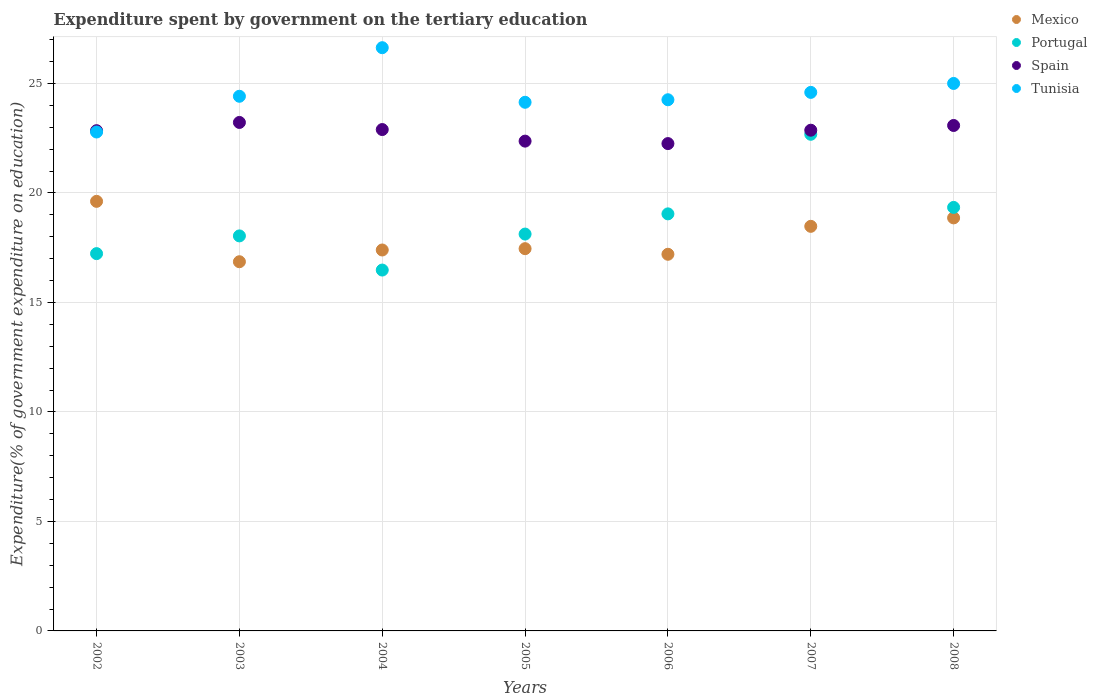Is the number of dotlines equal to the number of legend labels?
Provide a short and direct response. Yes. What is the expenditure spent by government on the tertiary education in Portugal in 2005?
Ensure brevity in your answer.  18.12. Across all years, what is the maximum expenditure spent by government on the tertiary education in Spain?
Make the answer very short. 23.22. Across all years, what is the minimum expenditure spent by government on the tertiary education in Spain?
Offer a terse response. 22.25. In which year was the expenditure spent by government on the tertiary education in Mexico maximum?
Make the answer very short. 2002. In which year was the expenditure spent by government on the tertiary education in Portugal minimum?
Make the answer very short. 2004. What is the total expenditure spent by government on the tertiary education in Tunisia in the graph?
Ensure brevity in your answer.  171.81. What is the difference between the expenditure spent by government on the tertiary education in Mexico in 2005 and that in 2006?
Give a very brief answer. 0.26. What is the difference between the expenditure spent by government on the tertiary education in Spain in 2008 and the expenditure spent by government on the tertiary education in Tunisia in 2007?
Make the answer very short. -1.51. What is the average expenditure spent by government on the tertiary education in Portugal per year?
Your answer should be very brief. 18.7. In the year 2007, what is the difference between the expenditure spent by government on the tertiary education in Tunisia and expenditure spent by government on the tertiary education in Portugal?
Your answer should be very brief. 1.91. In how many years, is the expenditure spent by government on the tertiary education in Tunisia greater than 2 %?
Provide a short and direct response. 7. What is the ratio of the expenditure spent by government on the tertiary education in Spain in 2002 to that in 2004?
Make the answer very short. 1. Is the expenditure spent by government on the tertiary education in Spain in 2006 less than that in 2008?
Ensure brevity in your answer.  Yes. What is the difference between the highest and the second highest expenditure spent by government on the tertiary education in Portugal?
Give a very brief answer. 3.34. What is the difference between the highest and the lowest expenditure spent by government on the tertiary education in Mexico?
Give a very brief answer. 2.76. Is the sum of the expenditure spent by government on the tertiary education in Mexico in 2003 and 2008 greater than the maximum expenditure spent by government on the tertiary education in Spain across all years?
Offer a terse response. Yes. Is it the case that in every year, the sum of the expenditure spent by government on the tertiary education in Mexico and expenditure spent by government on the tertiary education in Spain  is greater than the expenditure spent by government on the tertiary education in Portugal?
Keep it short and to the point. Yes. Does the expenditure spent by government on the tertiary education in Spain monotonically increase over the years?
Provide a short and direct response. No. Is the expenditure spent by government on the tertiary education in Spain strictly greater than the expenditure spent by government on the tertiary education in Mexico over the years?
Your response must be concise. Yes. Does the graph contain any zero values?
Provide a short and direct response. No. How are the legend labels stacked?
Offer a terse response. Vertical. What is the title of the graph?
Provide a succinct answer. Expenditure spent by government on the tertiary education. What is the label or title of the X-axis?
Give a very brief answer. Years. What is the label or title of the Y-axis?
Your answer should be compact. Expenditure(% of government expenditure on education). What is the Expenditure(% of government expenditure on education) in Mexico in 2002?
Your answer should be compact. 19.62. What is the Expenditure(% of government expenditure on education) in Portugal in 2002?
Your response must be concise. 17.23. What is the Expenditure(% of government expenditure on education) of Spain in 2002?
Make the answer very short. 22.84. What is the Expenditure(% of government expenditure on education) in Tunisia in 2002?
Your answer should be very brief. 22.78. What is the Expenditure(% of government expenditure on education) in Mexico in 2003?
Your answer should be compact. 16.86. What is the Expenditure(% of government expenditure on education) in Portugal in 2003?
Your answer should be very brief. 18.04. What is the Expenditure(% of government expenditure on education) of Spain in 2003?
Provide a short and direct response. 23.22. What is the Expenditure(% of government expenditure on education) of Tunisia in 2003?
Offer a very short reply. 24.41. What is the Expenditure(% of government expenditure on education) of Mexico in 2004?
Your answer should be very brief. 17.39. What is the Expenditure(% of government expenditure on education) in Portugal in 2004?
Keep it short and to the point. 16.48. What is the Expenditure(% of government expenditure on education) in Spain in 2004?
Your response must be concise. 22.89. What is the Expenditure(% of government expenditure on education) in Tunisia in 2004?
Your answer should be very brief. 26.63. What is the Expenditure(% of government expenditure on education) in Mexico in 2005?
Make the answer very short. 17.45. What is the Expenditure(% of government expenditure on education) in Portugal in 2005?
Your response must be concise. 18.12. What is the Expenditure(% of government expenditure on education) of Spain in 2005?
Your answer should be compact. 22.37. What is the Expenditure(% of government expenditure on education) of Tunisia in 2005?
Give a very brief answer. 24.14. What is the Expenditure(% of government expenditure on education) in Mexico in 2006?
Your response must be concise. 17.2. What is the Expenditure(% of government expenditure on education) of Portugal in 2006?
Offer a terse response. 19.04. What is the Expenditure(% of government expenditure on education) of Spain in 2006?
Provide a succinct answer. 22.25. What is the Expenditure(% of government expenditure on education) of Tunisia in 2006?
Offer a terse response. 24.25. What is the Expenditure(% of government expenditure on education) of Mexico in 2007?
Provide a succinct answer. 18.47. What is the Expenditure(% of government expenditure on education) of Portugal in 2007?
Offer a terse response. 22.68. What is the Expenditure(% of government expenditure on education) of Spain in 2007?
Your answer should be very brief. 22.86. What is the Expenditure(% of government expenditure on education) in Tunisia in 2007?
Keep it short and to the point. 24.59. What is the Expenditure(% of government expenditure on education) in Mexico in 2008?
Offer a very short reply. 18.86. What is the Expenditure(% of government expenditure on education) of Portugal in 2008?
Give a very brief answer. 19.34. What is the Expenditure(% of government expenditure on education) in Spain in 2008?
Your response must be concise. 23.08. What is the Expenditure(% of government expenditure on education) in Tunisia in 2008?
Your answer should be compact. 25. Across all years, what is the maximum Expenditure(% of government expenditure on education) in Mexico?
Make the answer very short. 19.62. Across all years, what is the maximum Expenditure(% of government expenditure on education) of Portugal?
Give a very brief answer. 22.68. Across all years, what is the maximum Expenditure(% of government expenditure on education) of Spain?
Offer a very short reply. 23.22. Across all years, what is the maximum Expenditure(% of government expenditure on education) in Tunisia?
Offer a terse response. 26.63. Across all years, what is the minimum Expenditure(% of government expenditure on education) in Mexico?
Offer a very short reply. 16.86. Across all years, what is the minimum Expenditure(% of government expenditure on education) in Portugal?
Offer a terse response. 16.48. Across all years, what is the minimum Expenditure(% of government expenditure on education) of Spain?
Make the answer very short. 22.25. Across all years, what is the minimum Expenditure(% of government expenditure on education) in Tunisia?
Your answer should be very brief. 22.78. What is the total Expenditure(% of government expenditure on education) in Mexico in the graph?
Provide a short and direct response. 125.86. What is the total Expenditure(% of government expenditure on education) of Portugal in the graph?
Make the answer very short. 130.93. What is the total Expenditure(% of government expenditure on education) in Spain in the graph?
Your answer should be very brief. 159.52. What is the total Expenditure(% of government expenditure on education) in Tunisia in the graph?
Your answer should be compact. 171.81. What is the difference between the Expenditure(% of government expenditure on education) of Mexico in 2002 and that in 2003?
Provide a short and direct response. 2.76. What is the difference between the Expenditure(% of government expenditure on education) in Portugal in 2002 and that in 2003?
Your response must be concise. -0.81. What is the difference between the Expenditure(% of government expenditure on education) of Spain in 2002 and that in 2003?
Your answer should be very brief. -0.38. What is the difference between the Expenditure(% of government expenditure on education) of Tunisia in 2002 and that in 2003?
Provide a succinct answer. -1.63. What is the difference between the Expenditure(% of government expenditure on education) of Mexico in 2002 and that in 2004?
Your answer should be compact. 2.22. What is the difference between the Expenditure(% of government expenditure on education) of Portugal in 2002 and that in 2004?
Your response must be concise. 0.75. What is the difference between the Expenditure(% of government expenditure on education) in Spain in 2002 and that in 2004?
Keep it short and to the point. -0.05. What is the difference between the Expenditure(% of government expenditure on education) in Tunisia in 2002 and that in 2004?
Your answer should be compact. -3.85. What is the difference between the Expenditure(% of government expenditure on education) in Mexico in 2002 and that in 2005?
Your answer should be compact. 2.16. What is the difference between the Expenditure(% of government expenditure on education) of Portugal in 2002 and that in 2005?
Make the answer very short. -0.89. What is the difference between the Expenditure(% of government expenditure on education) of Spain in 2002 and that in 2005?
Ensure brevity in your answer.  0.48. What is the difference between the Expenditure(% of government expenditure on education) of Tunisia in 2002 and that in 2005?
Keep it short and to the point. -1.36. What is the difference between the Expenditure(% of government expenditure on education) of Mexico in 2002 and that in 2006?
Keep it short and to the point. 2.42. What is the difference between the Expenditure(% of government expenditure on education) of Portugal in 2002 and that in 2006?
Provide a succinct answer. -1.82. What is the difference between the Expenditure(% of government expenditure on education) of Spain in 2002 and that in 2006?
Offer a very short reply. 0.59. What is the difference between the Expenditure(% of government expenditure on education) of Tunisia in 2002 and that in 2006?
Your answer should be compact. -1.47. What is the difference between the Expenditure(% of government expenditure on education) in Mexico in 2002 and that in 2007?
Make the answer very short. 1.14. What is the difference between the Expenditure(% of government expenditure on education) in Portugal in 2002 and that in 2007?
Keep it short and to the point. -5.45. What is the difference between the Expenditure(% of government expenditure on education) of Spain in 2002 and that in 2007?
Your answer should be very brief. -0.02. What is the difference between the Expenditure(% of government expenditure on education) in Tunisia in 2002 and that in 2007?
Make the answer very short. -1.81. What is the difference between the Expenditure(% of government expenditure on education) in Mexico in 2002 and that in 2008?
Keep it short and to the point. 0.76. What is the difference between the Expenditure(% of government expenditure on education) of Portugal in 2002 and that in 2008?
Your answer should be very brief. -2.11. What is the difference between the Expenditure(% of government expenditure on education) in Spain in 2002 and that in 2008?
Make the answer very short. -0.24. What is the difference between the Expenditure(% of government expenditure on education) of Tunisia in 2002 and that in 2008?
Your answer should be very brief. -2.22. What is the difference between the Expenditure(% of government expenditure on education) in Mexico in 2003 and that in 2004?
Give a very brief answer. -0.54. What is the difference between the Expenditure(% of government expenditure on education) in Portugal in 2003 and that in 2004?
Give a very brief answer. 1.56. What is the difference between the Expenditure(% of government expenditure on education) of Spain in 2003 and that in 2004?
Provide a short and direct response. 0.32. What is the difference between the Expenditure(% of government expenditure on education) of Tunisia in 2003 and that in 2004?
Your response must be concise. -2.22. What is the difference between the Expenditure(% of government expenditure on education) in Mexico in 2003 and that in 2005?
Keep it short and to the point. -0.6. What is the difference between the Expenditure(% of government expenditure on education) of Portugal in 2003 and that in 2005?
Make the answer very short. -0.08. What is the difference between the Expenditure(% of government expenditure on education) of Spain in 2003 and that in 2005?
Your answer should be very brief. 0.85. What is the difference between the Expenditure(% of government expenditure on education) of Tunisia in 2003 and that in 2005?
Give a very brief answer. 0.27. What is the difference between the Expenditure(% of government expenditure on education) of Mexico in 2003 and that in 2006?
Ensure brevity in your answer.  -0.34. What is the difference between the Expenditure(% of government expenditure on education) of Portugal in 2003 and that in 2006?
Make the answer very short. -1.01. What is the difference between the Expenditure(% of government expenditure on education) in Spain in 2003 and that in 2006?
Your answer should be very brief. 0.97. What is the difference between the Expenditure(% of government expenditure on education) of Tunisia in 2003 and that in 2006?
Give a very brief answer. 0.16. What is the difference between the Expenditure(% of government expenditure on education) of Mexico in 2003 and that in 2007?
Make the answer very short. -1.62. What is the difference between the Expenditure(% of government expenditure on education) in Portugal in 2003 and that in 2007?
Keep it short and to the point. -4.64. What is the difference between the Expenditure(% of government expenditure on education) of Spain in 2003 and that in 2007?
Give a very brief answer. 0.35. What is the difference between the Expenditure(% of government expenditure on education) of Tunisia in 2003 and that in 2007?
Provide a succinct answer. -0.18. What is the difference between the Expenditure(% of government expenditure on education) of Mexico in 2003 and that in 2008?
Make the answer very short. -2. What is the difference between the Expenditure(% of government expenditure on education) in Portugal in 2003 and that in 2008?
Keep it short and to the point. -1.3. What is the difference between the Expenditure(% of government expenditure on education) of Spain in 2003 and that in 2008?
Ensure brevity in your answer.  0.14. What is the difference between the Expenditure(% of government expenditure on education) in Tunisia in 2003 and that in 2008?
Offer a very short reply. -0.59. What is the difference between the Expenditure(% of government expenditure on education) in Mexico in 2004 and that in 2005?
Ensure brevity in your answer.  -0.06. What is the difference between the Expenditure(% of government expenditure on education) of Portugal in 2004 and that in 2005?
Make the answer very short. -1.64. What is the difference between the Expenditure(% of government expenditure on education) in Spain in 2004 and that in 2005?
Make the answer very short. 0.53. What is the difference between the Expenditure(% of government expenditure on education) in Tunisia in 2004 and that in 2005?
Offer a terse response. 2.49. What is the difference between the Expenditure(% of government expenditure on education) in Mexico in 2004 and that in 2006?
Offer a terse response. 0.2. What is the difference between the Expenditure(% of government expenditure on education) of Portugal in 2004 and that in 2006?
Your answer should be compact. -2.57. What is the difference between the Expenditure(% of government expenditure on education) of Spain in 2004 and that in 2006?
Provide a succinct answer. 0.64. What is the difference between the Expenditure(% of government expenditure on education) of Tunisia in 2004 and that in 2006?
Keep it short and to the point. 2.38. What is the difference between the Expenditure(% of government expenditure on education) of Mexico in 2004 and that in 2007?
Ensure brevity in your answer.  -1.08. What is the difference between the Expenditure(% of government expenditure on education) of Portugal in 2004 and that in 2007?
Your answer should be very brief. -6.2. What is the difference between the Expenditure(% of government expenditure on education) in Tunisia in 2004 and that in 2007?
Make the answer very short. 2.04. What is the difference between the Expenditure(% of government expenditure on education) of Mexico in 2004 and that in 2008?
Make the answer very short. -1.47. What is the difference between the Expenditure(% of government expenditure on education) of Portugal in 2004 and that in 2008?
Make the answer very short. -2.86. What is the difference between the Expenditure(% of government expenditure on education) in Spain in 2004 and that in 2008?
Your answer should be very brief. -0.19. What is the difference between the Expenditure(% of government expenditure on education) of Tunisia in 2004 and that in 2008?
Provide a succinct answer. 1.63. What is the difference between the Expenditure(% of government expenditure on education) of Mexico in 2005 and that in 2006?
Provide a succinct answer. 0.26. What is the difference between the Expenditure(% of government expenditure on education) in Portugal in 2005 and that in 2006?
Ensure brevity in your answer.  -0.92. What is the difference between the Expenditure(% of government expenditure on education) of Spain in 2005 and that in 2006?
Provide a succinct answer. 0.11. What is the difference between the Expenditure(% of government expenditure on education) of Tunisia in 2005 and that in 2006?
Make the answer very short. -0.12. What is the difference between the Expenditure(% of government expenditure on education) of Mexico in 2005 and that in 2007?
Offer a terse response. -1.02. What is the difference between the Expenditure(% of government expenditure on education) of Portugal in 2005 and that in 2007?
Offer a terse response. -4.56. What is the difference between the Expenditure(% of government expenditure on education) in Spain in 2005 and that in 2007?
Provide a short and direct response. -0.5. What is the difference between the Expenditure(% of government expenditure on education) of Tunisia in 2005 and that in 2007?
Provide a succinct answer. -0.45. What is the difference between the Expenditure(% of government expenditure on education) in Mexico in 2005 and that in 2008?
Ensure brevity in your answer.  -1.41. What is the difference between the Expenditure(% of government expenditure on education) of Portugal in 2005 and that in 2008?
Your answer should be compact. -1.22. What is the difference between the Expenditure(% of government expenditure on education) in Spain in 2005 and that in 2008?
Give a very brief answer. -0.71. What is the difference between the Expenditure(% of government expenditure on education) of Tunisia in 2005 and that in 2008?
Your answer should be very brief. -0.86. What is the difference between the Expenditure(% of government expenditure on education) of Mexico in 2006 and that in 2007?
Provide a short and direct response. -1.28. What is the difference between the Expenditure(% of government expenditure on education) in Portugal in 2006 and that in 2007?
Keep it short and to the point. -3.63. What is the difference between the Expenditure(% of government expenditure on education) in Spain in 2006 and that in 2007?
Your response must be concise. -0.61. What is the difference between the Expenditure(% of government expenditure on education) in Tunisia in 2006 and that in 2007?
Give a very brief answer. -0.34. What is the difference between the Expenditure(% of government expenditure on education) of Mexico in 2006 and that in 2008?
Give a very brief answer. -1.66. What is the difference between the Expenditure(% of government expenditure on education) of Portugal in 2006 and that in 2008?
Offer a very short reply. -0.3. What is the difference between the Expenditure(% of government expenditure on education) in Spain in 2006 and that in 2008?
Your answer should be compact. -0.83. What is the difference between the Expenditure(% of government expenditure on education) of Tunisia in 2006 and that in 2008?
Keep it short and to the point. -0.74. What is the difference between the Expenditure(% of government expenditure on education) in Mexico in 2007 and that in 2008?
Provide a succinct answer. -0.39. What is the difference between the Expenditure(% of government expenditure on education) in Portugal in 2007 and that in 2008?
Your answer should be compact. 3.34. What is the difference between the Expenditure(% of government expenditure on education) of Spain in 2007 and that in 2008?
Your response must be concise. -0.22. What is the difference between the Expenditure(% of government expenditure on education) in Tunisia in 2007 and that in 2008?
Give a very brief answer. -0.41. What is the difference between the Expenditure(% of government expenditure on education) of Mexico in 2002 and the Expenditure(% of government expenditure on education) of Portugal in 2003?
Provide a succinct answer. 1.58. What is the difference between the Expenditure(% of government expenditure on education) of Mexico in 2002 and the Expenditure(% of government expenditure on education) of Spain in 2003?
Offer a terse response. -3.6. What is the difference between the Expenditure(% of government expenditure on education) in Mexico in 2002 and the Expenditure(% of government expenditure on education) in Tunisia in 2003?
Provide a short and direct response. -4.8. What is the difference between the Expenditure(% of government expenditure on education) of Portugal in 2002 and the Expenditure(% of government expenditure on education) of Spain in 2003?
Offer a very short reply. -5.99. What is the difference between the Expenditure(% of government expenditure on education) in Portugal in 2002 and the Expenditure(% of government expenditure on education) in Tunisia in 2003?
Give a very brief answer. -7.19. What is the difference between the Expenditure(% of government expenditure on education) of Spain in 2002 and the Expenditure(% of government expenditure on education) of Tunisia in 2003?
Provide a succinct answer. -1.57. What is the difference between the Expenditure(% of government expenditure on education) in Mexico in 2002 and the Expenditure(% of government expenditure on education) in Portugal in 2004?
Provide a short and direct response. 3.14. What is the difference between the Expenditure(% of government expenditure on education) in Mexico in 2002 and the Expenditure(% of government expenditure on education) in Spain in 2004?
Ensure brevity in your answer.  -3.28. What is the difference between the Expenditure(% of government expenditure on education) in Mexico in 2002 and the Expenditure(% of government expenditure on education) in Tunisia in 2004?
Make the answer very short. -7.02. What is the difference between the Expenditure(% of government expenditure on education) of Portugal in 2002 and the Expenditure(% of government expenditure on education) of Spain in 2004?
Your answer should be very brief. -5.67. What is the difference between the Expenditure(% of government expenditure on education) in Portugal in 2002 and the Expenditure(% of government expenditure on education) in Tunisia in 2004?
Provide a succinct answer. -9.4. What is the difference between the Expenditure(% of government expenditure on education) in Spain in 2002 and the Expenditure(% of government expenditure on education) in Tunisia in 2004?
Give a very brief answer. -3.79. What is the difference between the Expenditure(% of government expenditure on education) in Mexico in 2002 and the Expenditure(% of government expenditure on education) in Portugal in 2005?
Offer a very short reply. 1.49. What is the difference between the Expenditure(% of government expenditure on education) of Mexico in 2002 and the Expenditure(% of government expenditure on education) of Spain in 2005?
Provide a succinct answer. -2.75. What is the difference between the Expenditure(% of government expenditure on education) of Mexico in 2002 and the Expenditure(% of government expenditure on education) of Tunisia in 2005?
Your answer should be very brief. -4.52. What is the difference between the Expenditure(% of government expenditure on education) in Portugal in 2002 and the Expenditure(% of government expenditure on education) in Spain in 2005?
Your answer should be compact. -5.14. What is the difference between the Expenditure(% of government expenditure on education) in Portugal in 2002 and the Expenditure(% of government expenditure on education) in Tunisia in 2005?
Provide a succinct answer. -6.91. What is the difference between the Expenditure(% of government expenditure on education) of Spain in 2002 and the Expenditure(% of government expenditure on education) of Tunisia in 2005?
Provide a short and direct response. -1.3. What is the difference between the Expenditure(% of government expenditure on education) in Mexico in 2002 and the Expenditure(% of government expenditure on education) in Portugal in 2006?
Your answer should be compact. 0.57. What is the difference between the Expenditure(% of government expenditure on education) in Mexico in 2002 and the Expenditure(% of government expenditure on education) in Spain in 2006?
Ensure brevity in your answer.  -2.64. What is the difference between the Expenditure(% of government expenditure on education) in Mexico in 2002 and the Expenditure(% of government expenditure on education) in Tunisia in 2006?
Make the answer very short. -4.64. What is the difference between the Expenditure(% of government expenditure on education) in Portugal in 2002 and the Expenditure(% of government expenditure on education) in Spain in 2006?
Provide a succinct answer. -5.02. What is the difference between the Expenditure(% of government expenditure on education) in Portugal in 2002 and the Expenditure(% of government expenditure on education) in Tunisia in 2006?
Give a very brief answer. -7.03. What is the difference between the Expenditure(% of government expenditure on education) in Spain in 2002 and the Expenditure(% of government expenditure on education) in Tunisia in 2006?
Give a very brief answer. -1.41. What is the difference between the Expenditure(% of government expenditure on education) in Mexico in 2002 and the Expenditure(% of government expenditure on education) in Portugal in 2007?
Provide a succinct answer. -3.06. What is the difference between the Expenditure(% of government expenditure on education) of Mexico in 2002 and the Expenditure(% of government expenditure on education) of Spain in 2007?
Provide a short and direct response. -3.25. What is the difference between the Expenditure(% of government expenditure on education) in Mexico in 2002 and the Expenditure(% of government expenditure on education) in Tunisia in 2007?
Your response must be concise. -4.98. What is the difference between the Expenditure(% of government expenditure on education) of Portugal in 2002 and the Expenditure(% of government expenditure on education) of Spain in 2007?
Provide a succinct answer. -5.64. What is the difference between the Expenditure(% of government expenditure on education) in Portugal in 2002 and the Expenditure(% of government expenditure on education) in Tunisia in 2007?
Offer a very short reply. -7.36. What is the difference between the Expenditure(% of government expenditure on education) of Spain in 2002 and the Expenditure(% of government expenditure on education) of Tunisia in 2007?
Provide a succinct answer. -1.75. What is the difference between the Expenditure(% of government expenditure on education) of Mexico in 2002 and the Expenditure(% of government expenditure on education) of Portugal in 2008?
Make the answer very short. 0.28. What is the difference between the Expenditure(% of government expenditure on education) in Mexico in 2002 and the Expenditure(% of government expenditure on education) in Spain in 2008?
Make the answer very short. -3.46. What is the difference between the Expenditure(% of government expenditure on education) in Mexico in 2002 and the Expenditure(% of government expenditure on education) in Tunisia in 2008?
Provide a succinct answer. -5.38. What is the difference between the Expenditure(% of government expenditure on education) of Portugal in 2002 and the Expenditure(% of government expenditure on education) of Spain in 2008?
Your response must be concise. -5.85. What is the difference between the Expenditure(% of government expenditure on education) in Portugal in 2002 and the Expenditure(% of government expenditure on education) in Tunisia in 2008?
Your response must be concise. -7.77. What is the difference between the Expenditure(% of government expenditure on education) in Spain in 2002 and the Expenditure(% of government expenditure on education) in Tunisia in 2008?
Provide a short and direct response. -2.16. What is the difference between the Expenditure(% of government expenditure on education) of Mexico in 2003 and the Expenditure(% of government expenditure on education) of Portugal in 2004?
Provide a short and direct response. 0.38. What is the difference between the Expenditure(% of government expenditure on education) in Mexico in 2003 and the Expenditure(% of government expenditure on education) in Spain in 2004?
Your answer should be very brief. -6.04. What is the difference between the Expenditure(% of government expenditure on education) in Mexico in 2003 and the Expenditure(% of government expenditure on education) in Tunisia in 2004?
Your answer should be very brief. -9.77. What is the difference between the Expenditure(% of government expenditure on education) of Portugal in 2003 and the Expenditure(% of government expenditure on education) of Spain in 2004?
Your answer should be compact. -4.86. What is the difference between the Expenditure(% of government expenditure on education) of Portugal in 2003 and the Expenditure(% of government expenditure on education) of Tunisia in 2004?
Keep it short and to the point. -8.59. What is the difference between the Expenditure(% of government expenditure on education) in Spain in 2003 and the Expenditure(% of government expenditure on education) in Tunisia in 2004?
Your answer should be very brief. -3.41. What is the difference between the Expenditure(% of government expenditure on education) of Mexico in 2003 and the Expenditure(% of government expenditure on education) of Portugal in 2005?
Offer a very short reply. -1.26. What is the difference between the Expenditure(% of government expenditure on education) of Mexico in 2003 and the Expenditure(% of government expenditure on education) of Spain in 2005?
Ensure brevity in your answer.  -5.51. What is the difference between the Expenditure(% of government expenditure on education) of Mexico in 2003 and the Expenditure(% of government expenditure on education) of Tunisia in 2005?
Ensure brevity in your answer.  -7.28. What is the difference between the Expenditure(% of government expenditure on education) of Portugal in 2003 and the Expenditure(% of government expenditure on education) of Spain in 2005?
Provide a succinct answer. -4.33. What is the difference between the Expenditure(% of government expenditure on education) in Portugal in 2003 and the Expenditure(% of government expenditure on education) in Tunisia in 2005?
Ensure brevity in your answer.  -6.1. What is the difference between the Expenditure(% of government expenditure on education) of Spain in 2003 and the Expenditure(% of government expenditure on education) of Tunisia in 2005?
Make the answer very short. -0.92. What is the difference between the Expenditure(% of government expenditure on education) of Mexico in 2003 and the Expenditure(% of government expenditure on education) of Portugal in 2006?
Your answer should be compact. -2.19. What is the difference between the Expenditure(% of government expenditure on education) in Mexico in 2003 and the Expenditure(% of government expenditure on education) in Spain in 2006?
Your answer should be very brief. -5.39. What is the difference between the Expenditure(% of government expenditure on education) of Mexico in 2003 and the Expenditure(% of government expenditure on education) of Tunisia in 2006?
Provide a succinct answer. -7.4. What is the difference between the Expenditure(% of government expenditure on education) in Portugal in 2003 and the Expenditure(% of government expenditure on education) in Spain in 2006?
Provide a short and direct response. -4.22. What is the difference between the Expenditure(% of government expenditure on education) in Portugal in 2003 and the Expenditure(% of government expenditure on education) in Tunisia in 2006?
Offer a terse response. -6.22. What is the difference between the Expenditure(% of government expenditure on education) in Spain in 2003 and the Expenditure(% of government expenditure on education) in Tunisia in 2006?
Provide a succinct answer. -1.04. What is the difference between the Expenditure(% of government expenditure on education) of Mexico in 2003 and the Expenditure(% of government expenditure on education) of Portugal in 2007?
Offer a very short reply. -5.82. What is the difference between the Expenditure(% of government expenditure on education) of Mexico in 2003 and the Expenditure(% of government expenditure on education) of Spain in 2007?
Provide a short and direct response. -6.01. What is the difference between the Expenditure(% of government expenditure on education) of Mexico in 2003 and the Expenditure(% of government expenditure on education) of Tunisia in 2007?
Ensure brevity in your answer.  -7.73. What is the difference between the Expenditure(% of government expenditure on education) of Portugal in 2003 and the Expenditure(% of government expenditure on education) of Spain in 2007?
Ensure brevity in your answer.  -4.83. What is the difference between the Expenditure(% of government expenditure on education) in Portugal in 2003 and the Expenditure(% of government expenditure on education) in Tunisia in 2007?
Offer a very short reply. -6.55. What is the difference between the Expenditure(% of government expenditure on education) in Spain in 2003 and the Expenditure(% of government expenditure on education) in Tunisia in 2007?
Your answer should be compact. -1.37. What is the difference between the Expenditure(% of government expenditure on education) of Mexico in 2003 and the Expenditure(% of government expenditure on education) of Portugal in 2008?
Provide a short and direct response. -2.48. What is the difference between the Expenditure(% of government expenditure on education) of Mexico in 2003 and the Expenditure(% of government expenditure on education) of Spain in 2008?
Your answer should be compact. -6.22. What is the difference between the Expenditure(% of government expenditure on education) of Mexico in 2003 and the Expenditure(% of government expenditure on education) of Tunisia in 2008?
Your answer should be very brief. -8.14. What is the difference between the Expenditure(% of government expenditure on education) in Portugal in 2003 and the Expenditure(% of government expenditure on education) in Spain in 2008?
Provide a succinct answer. -5.04. What is the difference between the Expenditure(% of government expenditure on education) of Portugal in 2003 and the Expenditure(% of government expenditure on education) of Tunisia in 2008?
Give a very brief answer. -6.96. What is the difference between the Expenditure(% of government expenditure on education) of Spain in 2003 and the Expenditure(% of government expenditure on education) of Tunisia in 2008?
Give a very brief answer. -1.78. What is the difference between the Expenditure(% of government expenditure on education) of Mexico in 2004 and the Expenditure(% of government expenditure on education) of Portugal in 2005?
Ensure brevity in your answer.  -0.73. What is the difference between the Expenditure(% of government expenditure on education) of Mexico in 2004 and the Expenditure(% of government expenditure on education) of Spain in 2005?
Ensure brevity in your answer.  -4.97. What is the difference between the Expenditure(% of government expenditure on education) in Mexico in 2004 and the Expenditure(% of government expenditure on education) in Tunisia in 2005?
Offer a very short reply. -6.75. What is the difference between the Expenditure(% of government expenditure on education) in Portugal in 2004 and the Expenditure(% of government expenditure on education) in Spain in 2005?
Offer a terse response. -5.89. What is the difference between the Expenditure(% of government expenditure on education) of Portugal in 2004 and the Expenditure(% of government expenditure on education) of Tunisia in 2005?
Give a very brief answer. -7.66. What is the difference between the Expenditure(% of government expenditure on education) in Spain in 2004 and the Expenditure(% of government expenditure on education) in Tunisia in 2005?
Your response must be concise. -1.25. What is the difference between the Expenditure(% of government expenditure on education) of Mexico in 2004 and the Expenditure(% of government expenditure on education) of Portugal in 2006?
Your response must be concise. -1.65. What is the difference between the Expenditure(% of government expenditure on education) of Mexico in 2004 and the Expenditure(% of government expenditure on education) of Spain in 2006?
Offer a terse response. -4.86. What is the difference between the Expenditure(% of government expenditure on education) in Mexico in 2004 and the Expenditure(% of government expenditure on education) in Tunisia in 2006?
Give a very brief answer. -6.86. What is the difference between the Expenditure(% of government expenditure on education) in Portugal in 2004 and the Expenditure(% of government expenditure on education) in Spain in 2006?
Offer a terse response. -5.77. What is the difference between the Expenditure(% of government expenditure on education) in Portugal in 2004 and the Expenditure(% of government expenditure on education) in Tunisia in 2006?
Your answer should be very brief. -7.78. What is the difference between the Expenditure(% of government expenditure on education) of Spain in 2004 and the Expenditure(% of government expenditure on education) of Tunisia in 2006?
Offer a terse response. -1.36. What is the difference between the Expenditure(% of government expenditure on education) of Mexico in 2004 and the Expenditure(% of government expenditure on education) of Portugal in 2007?
Provide a succinct answer. -5.28. What is the difference between the Expenditure(% of government expenditure on education) of Mexico in 2004 and the Expenditure(% of government expenditure on education) of Spain in 2007?
Give a very brief answer. -5.47. What is the difference between the Expenditure(% of government expenditure on education) of Mexico in 2004 and the Expenditure(% of government expenditure on education) of Tunisia in 2007?
Provide a short and direct response. -7.2. What is the difference between the Expenditure(% of government expenditure on education) in Portugal in 2004 and the Expenditure(% of government expenditure on education) in Spain in 2007?
Your answer should be compact. -6.39. What is the difference between the Expenditure(% of government expenditure on education) in Portugal in 2004 and the Expenditure(% of government expenditure on education) in Tunisia in 2007?
Offer a terse response. -8.11. What is the difference between the Expenditure(% of government expenditure on education) of Spain in 2004 and the Expenditure(% of government expenditure on education) of Tunisia in 2007?
Your answer should be compact. -1.7. What is the difference between the Expenditure(% of government expenditure on education) of Mexico in 2004 and the Expenditure(% of government expenditure on education) of Portugal in 2008?
Offer a very short reply. -1.94. What is the difference between the Expenditure(% of government expenditure on education) in Mexico in 2004 and the Expenditure(% of government expenditure on education) in Spain in 2008?
Provide a short and direct response. -5.69. What is the difference between the Expenditure(% of government expenditure on education) in Mexico in 2004 and the Expenditure(% of government expenditure on education) in Tunisia in 2008?
Provide a short and direct response. -7.6. What is the difference between the Expenditure(% of government expenditure on education) in Portugal in 2004 and the Expenditure(% of government expenditure on education) in Spain in 2008?
Your response must be concise. -6.6. What is the difference between the Expenditure(% of government expenditure on education) of Portugal in 2004 and the Expenditure(% of government expenditure on education) of Tunisia in 2008?
Keep it short and to the point. -8.52. What is the difference between the Expenditure(% of government expenditure on education) of Spain in 2004 and the Expenditure(% of government expenditure on education) of Tunisia in 2008?
Keep it short and to the point. -2.11. What is the difference between the Expenditure(% of government expenditure on education) in Mexico in 2005 and the Expenditure(% of government expenditure on education) in Portugal in 2006?
Your answer should be very brief. -1.59. What is the difference between the Expenditure(% of government expenditure on education) of Mexico in 2005 and the Expenditure(% of government expenditure on education) of Spain in 2006?
Offer a terse response. -4.8. What is the difference between the Expenditure(% of government expenditure on education) of Mexico in 2005 and the Expenditure(% of government expenditure on education) of Tunisia in 2006?
Your answer should be compact. -6.8. What is the difference between the Expenditure(% of government expenditure on education) of Portugal in 2005 and the Expenditure(% of government expenditure on education) of Spain in 2006?
Offer a terse response. -4.13. What is the difference between the Expenditure(% of government expenditure on education) of Portugal in 2005 and the Expenditure(% of government expenditure on education) of Tunisia in 2006?
Your answer should be compact. -6.13. What is the difference between the Expenditure(% of government expenditure on education) of Spain in 2005 and the Expenditure(% of government expenditure on education) of Tunisia in 2006?
Offer a terse response. -1.89. What is the difference between the Expenditure(% of government expenditure on education) of Mexico in 2005 and the Expenditure(% of government expenditure on education) of Portugal in 2007?
Offer a terse response. -5.22. What is the difference between the Expenditure(% of government expenditure on education) in Mexico in 2005 and the Expenditure(% of government expenditure on education) in Spain in 2007?
Provide a short and direct response. -5.41. What is the difference between the Expenditure(% of government expenditure on education) in Mexico in 2005 and the Expenditure(% of government expenditure on education) in Tunisia in 2007?
Provide a short and direct response. -7.14. What is the difference between the Expenditure(% of government expenditure on education) of Portugal in 2005 and the Expenditure(% of government expenditure on education) of Spain in 2007?
Your answer should be very brief. -4.74. What is the difference between the Expenditure(% of government expenditure on education) of Portugal in 2005 and the Expenditure(% of government expenditure on education) of Tunisia in 2007?
Give a very brief answer. -6.47. What is the difference between the Expenditure(% of government expenditure on education) in Spain in 2005 and the Expenditure(% of government expenditure on education) in Tunisia in 2007?
Give a very brief answer. -2.23. What is the difference between the Expenditure(% of government expenditure on education) in Mexico in 2005 and the Expenditure(% of government expenditure on education) in Portugal in 2008?
Provide a succinct answer. -1.88. What is the difference between the Expenditure(% of government expenditure on education) in Mexico in 2005 and the Expenditure(% of government expenditure on education) in Spain in 2008?
Give a very brief answer. -5.62. What is the difference between the Expenditure(% of government expenditure on education) of Mexico in 2005 and the Expenditure(% of government expenditure on education) of Tunisia in 2008?
Offer a terse response. -7.54. What is the difference between the Expenditure(% of government expenditure on education) of Portugal in 2005 and the Expenditure(% of government expenditure on education) of Spain in 2008?
Provide a short and direct response. -4.96. What is the difference between the Expenditure(% of government expenditure on education) of Portugal in 2005 and the Expenditure(% of government expenditure on education) of Tunisia in 2008?
Your answer should be very brief. -6.88. What is the difference between the Expenditure(% of government expenditure on education) of Spain in 2005 and the Expenditure(% of government expenditure on education) of Tunisia in 2008?
Your response must be concise. -2.63. What is the difference between the Expenditure(% of government expenditure on education) in Mexico in 2006 and the Expenditure(% of government expenditure on education) in Portugal in 2007?
Give a very brief answer. -5.48. What is the difference between the Expenditure(% of government expenditure on education) in Mexico in 2006 and the Expenditure(% of government expenditure on education) in Spain in 2007?
Give a very brief answer. -5.67. What is the difference between the Expenditure(% of government expenditure on education) in Mexico in 2006 and the Expenditure(% of government expenditure on education) in Tunisia in 2007?
Provide a succinct answer. -7.39. What is the difference between the Expenditure(% of government expenditure on education) in Portugal in 2006 and the Expenditure(% of government expenditure on education) in Spain in 2007?
Make the answer very short. -3.82. What is the difference between the Expenditure(% of government expenditure on education) in Portugal in 2006 and the Expenditure(% of government expenditure on education) in Tunisia in 2007?
Provide a succinct answer. -5.55. What is the difference between the Expenditure(% of government expenditure on education) in Spain in 2006 and the Expenditure(% of government expenditure on education) in Tunisia in 2007?
Give a very brief answer. -2.34. What is the difference between the Expenditure(% of government expenditure on education) of Mexico in 2006 and the Expenditure(% of government expenditure on education) of Portugal in 2008?
Offer a terse response. -2.14. What is the difference between the Expenditure(% of government expenditure on education) of Mexico in 2006 and the Expenditure(% of government expenditure on education) of Spain in 2008?
Provide a succinct answer. -5.88. What is the difference between the Expenditure(% of government expenditure on education) in Mexico in 2006 and the Expenditure(% of government expenditure on education) in Tunisia in 2008?
Offer a very short reply. -7.8. What is the difference between the Expenditure(% of government expenditure on education) of Portugal in 2006 and the Expenditure(% of government expenditure on education) of Spain in 2008?
Offer a very short reply. -4.04. What is the difference between the Expenditure(% of government expenditure on education) of Portugal in 2006 and the Expenditure(% of government expenditure on education) of Tunisia in 2008?
Give a very brief answer. -5.96. What is the difference between the Expenditure(% of government expenditure on education) of Spain in 2006 and the Expenditure(% of government expenditure on education) of Tunisia in 2008?
Your answer should be very brief. -2.75. What is the difference between the Expenditure(% of government expenditure on education) in Mexico in 2007 and the Expenditure(% of government expenditure on education) in Portugal in 2008?
Provide a short and direct response. -0.86. What is the difference between the Expenditure(% of government expenditure on education) of Mexico in 2007 and the Expenditure(% of government expenditure on education) of Spain in 2008?
Your response must be concise. -4.61. What is the difference between the Expenditure(% of government expenditure on education) in Mexico in 2007 and the Expenditure(% of government expenditure on education) in Tunisia in 2008?
Offer a very short reply. -6.52. What is the difference between the Expenditure(% of government expenditure on education) in Portugal in 2007 and the Expenditure(% of government expenditure on education) in Spain in 2008?
Ensure brevity in your answer.  -0.4. What is the difference between the Expenditure(% of government expenditure on education) in Portugal in 2007 and the Expenditure(% of government expenditure on education) in Tunisia in 2008?
Give a very brief answer. -2.32. What is the difference between the Expenditure(% of government expenditure on education) of Spain in 2007 and the Expenditure(% of government expenditure on education) of Tunisia in 2008?
Offer a terse response. -2.14. What is the average Expenditure(% of government expenditure on education) of Mexico per year?
Give a very brief answer. 17.98. What is the average Expenditure(% of government expenditure on education) in Portugal per year?
Give a very brief answer. 18.7. What is the average Expenditure(% of government expenditure on education) in Spain per year?
Your response must be concise. 22.79. What is the average Expenditure(% of government expenditure on education) of Tunisia per year?
Give a very brief answer. 24.54. In the year 2002, what is the difference between the Expenditure(% of government expenditure on education) in Mexico and Expenditure(% of government expenditure on education) in Portugal?
Your answer should be compact. 2.39. In the year 2002, what is the difference between the Expenditure(% of government expenditure on education) of Mexico and Expenditure(% of government expenditure on education) of Spain?
Keep it short and to the point. -3.23. In the year 2002, what is the difference between the Expenditure(% of government expenditure on education) in Mexico and Expenditure(% of government expenditure on education) in Tunisia?
Make the answer very short. -3.17. In the year 2002, what is the difference between the Expenditure(% of government expenditure on education) of Portugal and Expenditure(% of government expenditure on education) of Spain?
Keep it short and to the point. -5.61. In the year 2002, what is the difference between the Expenditure(% of government expenditure on education) in Portugal and Expenditure(% of government expenditure on education) in Tunisia?
Keep it short and to the point. -5.55. In the year 2003, what is the difference between the Expenditure(% of government expenditure on education) in Mexico and Expenditure(% of government expenditure on education) in Portugal?
Provide a short and direct response. -1.18. In the year 2003, what is the difference between the Expenditure(% of government expenditure on education) in Mexico and Expenditure(% of government expenditure on education) in Spain?
Your answer should be very brief. -6.36. In the year 2003, what is the difference between the Expenditure(% of government expenditure on education) of Mexico and Expenditure(% of government expenditure on education) of Tunisia?
Offer a very short reply. -7.56. In the year 2003, what is the difference between the Expenditure(% of government expenditure on education) in Portugal and Expenditure(% of government expenditure on education) in Spain?
Keep it short and to the point. -5.18. In the year 2003, what is the difference between the Expenditure(% of government expenditure on education) of Portugal and Expenditure(% of government expenditure on education) of Tunisia?
Keep it short and to the point. -6.38. In the year 2003, what is the difference between the Expenditure(% of government expenditure on education) of Spain and Expenditure(% of government expenditure on education) of Tunisia?
Give a very brief answer. -1.2. In the year 2004, what is the difference between the Expenditure(% of government expenditure on education) in Mexico and Expenditure(% of government expenditure on education) in Portugal?
Provide a short and direct response. 0.92. In the year 2004, what is the difference between the Expenditure(% of government expenditure on education) in Mexico and Expenditure(% of government expenditure on education) in Spain?
Give a very brief answer. -5.5. In the year 2004, what is the difference between the Expenditure(% of government expenditure on education) of Mexico and Expenditure(% of government expenditure on education) of Tunisia?
Ensure brevity in your answer.  -9.24. In the year 2004, what is the difference between the Expenditure(% of government expenditure on education) of Portugal and Expenditure(% of government expenditure on education) of Spain?
Your response must be concise. -6.42. In the year 2004, what is the difference between the Expenditure(% of government expenditure on education) of Portugal and Expenditure(% of government expenditure on education) of Tunisia?
Make the answer very short. -10.15. In the year 2004, what is the difference between the Expenditure(% of government expenditure on education) of Spain and Expenditure(% of government expenditure on education) of Tunisia?
Your answer should be compact. -3.74. In the year 2005, what is the difference between the Expenditure(% of government expenditure on education) of Mexico and Expenditure(% of government expenditure on education) of Portugal?
Your answer should be compact. -0.67. In the year 2005, what is the difference between the Expenditure(% of government expenditure on education) of Mexico and Expenditure(% of government expenditure on education) of Spain?
Your response must be concise. -4.91. In the year 2005, what is the difference between the Expenditure(% of government expenditure on education) of Mexico and Expenditure(% of government expenditure on education) of Tunisia?
Offer a terse response. -6.68. In the year 2005, what is the difference between the Expenditure(% of government expenditure on education) of Portugal and Expenditure(% of government expenditure on education) of Spain?
Your answer should be compact. -4.24. In the year 2005, what is the difference between the Expenditure(% of government expenditure on education) of Portugal and Expenditure(% of government expenditure on education) of Tunisia?
Keep it short and to the point. -6.02. In the year 2005, what is the difference between the Expenditure(% of government expenditure on education) in Spain and Expenditure(% of government expenditure on education) in Tunisia?
Offer a terse response. -1.77. In the year 2006, what is the difference between the Expenditure(% of government expenditure on education) in Mexico and Expenditure(% of government expenditure on education) in Portugal?
Offer a terse response. -1.84. In the year 2006, what is the difference between the Expenditure(% of government expenditure on education) of Mexico and Expenditure(% of government expenditure on education) of Spain?
Your response must be concise. -5.05. In the year 2006, what is the difference between the Expenditure(% of government expenditure on education) in Mexico and Expenditure(% of government expenditure on education) in Tunisia?
Keep it short and to the point. -7.06. In the year 2006, what is the difference between the Expenditure(% of government expenditure on education) of Portugal and Expenditure(% of government expenditure on education) of Spain?
Your answer should be compact. -3.21. In the year 2006, what is the difference between the Expenditure(% of government expenditure on education) of Portugal and Expenditure(% of government expenditure on education) of Tunisia?
Ensure brevity in your answer.  -5.21. In the year 2006, what is the difference between the Expenditure(% of government expenditure on education) in Spain and Expenditure(% of government expenditure on education) in Tunisia?
Offer a terse response. -2. In the year 2007, what is the difference between the Expenditure(% of government expenditure on education) of Mexico and Expenditure(% of government expenditure on education) of Portugal?
Ensure brevity in your answer.  -4.2. In the year 2007, what is the difference between the Expenditure(% of government expenditure on education) of Mexico and Expenditure(% of government expenditure on education) of Spain?
Provide a succinct answer. -4.39. In the year 2007, what is the difference between the Expenditure(% of government expenditure on education) of Mexico and Expenditure(% of government expenditure on education) of Tunisia?
Provide a succinct answer. -6.12. In the year 2007, what is the difference between the Expenditure(% of government expenditure on education) of Portugal and Expenditure(% of government expenditure on education) of Spain?
Give a very brief answer. -0.19. In the year 2007, what is the difference between the Expenditure(% of government expenditure on education) of Portugal and Expenditure(% of government expenditure on education) of Tunisia?
Keep it short and to the point. -1.91. In the year 2007, what is the difference between the Expenditure(% of government expenditure on education) of Spain and Expenditure(% of government expenditure on education) of Tunisia?
Offer a very short reply. -1.73. In the year 2008, what is the difference between the Expenditure(% of government expenditure on education) of Mexico and Expenditure(% of government expenditure on education) of Portugal?
Provide a succinct answer. -0.48. In the year 2008, what is the difference between the Expenditure(% of government expenditure on education) in Mexico and Expenditure(% of government expenditure on education) in Spain?
Offer a very short reply. -4.22. In the year 2008, what is the difference between the Expenditure(% of government expenditure on education) in Mexico and Expenditure(% of government expenditure on education) in Tunisia?
Offer a very short reply. -6.14. In the year 2008, what is the difference between the Expenditure(% of government expenditure on education) of Portugal and Expenditure(% of government expenditure on education) of Spain?
Provide a short and direct response. -3.74. In the year 2008, what is the difference between the Expenditure(% of government expenditure on education) in Portugal and Expenditure(% of government expenditure on education) in Tunisia?
Your response must be concise. -5.66. In the year 2008, what is the difference between the Expenditure(% of government expenditure on education) in Spain and Expenditure(% of government expenditure on education) in Tunisia?
Your answer should be compact. -1.92. What is the ratio of the Expenditure(% of government expenditure on education) in Mexico in 2002 to that in 2003?
Provide a short and direct response. 1.16. What is the ratio of the Expenditure(% of government expenditure on education) in Portugal in 2002 to that in 2003?
Make the answer very short. 0.96. What is the ratio of the Expenditure(% of government expenditure on education) in Spain in 2002 to that in 2003?
Keep it short and to the point. 0.98. What is the ratio of the Expenditure(% of government expenditure on education) in Tunisia in 2002 to that in 2003?
Offer a very short reply. 0.93. What is the ratio of the Expenditure(% of government expenditure on education) of Mexico in 2002 to that in 2004?
Give a very brief answer. 1.13. What is the ratio of the Expenditure(% of government expenditure on education) in Portugal in 2002 to that in 2004?
Provide a short and direct response. 1.05. What is the ratio of the Expenditure(% of government expenditure on education) in Tunisia in 2002 to that in 2004?
Offer a terse response. 0.86. What is the ratio of the Expenditure(% of government expenditure on education) of Mexico in 2002 to that in 2005?
Offer a very short reply. 1.12. What is the ratio of the Expenditure(% of government expenditure on education) of Portugal in 2002 to that in 2005?
Your response must be concise. 0.95. What is the ratio of the Expenditure(% of government expenditure on education) of Spain in 2002 to that in 2005?
Ensure brevity in your answer.  1.02. What is the ratio of the Expenditure(% of government expenditure on education) of Tunisia in 2002 to that in 2005?
Make the answer very short. 0.94. What is the ratio of the Expenditure(% of government expenditure on education) in Mexico in 2002 to that in 2006?
Keep it short and to the point. 1.14. What is the ratio of the Expenditure(% of government expenditure on education) in Portugal in 2002 to that in 2006?
Keep it short and to the point. 0.9. What is the ratio of the Expenditure(% of government expenditure on education) of Spain in 2002 to that in 2006?
Provide a succinct answer. 1.03. What is the ratio of the Expenditure(% of government expenditure on education) of Tunisia in 2002 to that in 2006?
Offer a terse response. 0.94. What is the ratio of the Expenditure(% of government expenditure on education) of Mexico in 2002 to that in 2007?
Offer a very short reply. 1.06. What is the ratio of the Expenditure(% of government expenditure on education) of Portugal in 2002 to that in 2007?
Offer a terse response. 0.76. What is the ratio of the Expenditure(% of government expenditure on education) of Tunisia in 2002 to that in 2007?
Your response must be concise. 0.93. What is the ratio of the Expenditure(% of government expenditure on education) in Portugal in 2002 to that in 2008?
Your answer should be very brief. 0.89. What is the ratio of the Expenditure(% of government expenditure on education) of Spain in 2002 to that in 2008?
Make the answer very short. 0.99. What is the ratio of the Expenditure(% of government expenditure on education) in Tunisia in 2002 to that in 2008?
Make the answer very short. 0.91. What is the ratio of the Expenditure(% of government expenditure on education) in Mexico in 2003 to that in 2004?
Provide a short and direct response. 0.97. What is the ratio of the Expenditure(% of government expenditure on education) in Portugal in 2003 to that in 2004?
Provide a short and direct response. 1.09. What is the ratio of the Expenditure(% of government expenditure on education) of Spain in 2003 to that in 2004?
Offer a very short reply. 1.01. What is the ratio of the Expenditure(% of government expenditure on education) in Tunisia in 2003 to that in 2004?
Provide a short and direct response. 0.92. What is the ratio of the Expenditure(% of government expenditure on education) of Mexico in 2003 to that in 2005?
Your answer should be compact. 0.97. What is the ratio of the Expenditure(% of government expenditure on education) of Portugal in 2003 to that in 2005?
Keep it short and to the point. 1. What is the ratio of the Expenditure(% of government expenditure on education) in Spain in 2003 to that in 2005?
Your response must be concise. 1.04. What is the ratio of the Expenditure(% of government expenditure on education) of Tunisia in 2003 to that in 2005?
Your answer should be very brief. 1.01. What is the ratio of the Expenditure(% of government expenditure on education) of Mexico in 2003 to that in 2006?
Offer a terse response. 0.98. What is the ratio of the Expenditure(% of government expenditure on education) of Portugal in 2003 to that in 2006?
Your response must be concise. 0.95. What is the ratio of the Expenditure(% of government expenditure on education) in Spain in 2003 to that in 2006?
Offer a terse response. 1.04. What is the ratio of the Expenditure(% of government expenditure on education) in Tunisia in 2003 to that in 2006?
Your answer should be very brief. 1.01. What is the ratio of the Expenditure(% of government expenditure on education) in Mexico in 2003 to that in 2007?
Your response must be concise. 0.91. What is the ratio of the Expenditure(% of government expenditure on education) of Portugal in 2003 to that in 2007?
Your answer should be very brief. 0.8. What is the ratio of the Expenditure(% of government expenditure on education) of Spain in 2003 to that in 2007?
Give a very brief answer. 1.02. What is the ratio of the Expenditure(% of government expenditure on education) in Mexico in 2003 to that in 2008?
Make the answer very short. 0.89. What is the ratio of the Expenditure(% of government expenditure on education) of Portugal in 2003 to that in 2008?
Your answer should be very brief. 0.93. What is the ratio of the Expenditure(% of government expenditure on education) of Spain in 2003 to that in 2008?
Your answer should be very brief. 1.01. What is the ratio of the Expenditure(% of government expenditure on education) of Tunisia in 2003 to that in 2008?
Your answer should be very brief. 0.98. What is the ratio of the Expenditure(% of government expenditure on education) of Mexico in 2004 to that in 2005?
Ensure brevity in your answer.  1. What is the ratio of the Expenditure(% of government expenditure on education) of Portugal in 2004 to that in 2005?
Keep it short and to the point. 0.91. What is the ratio of the Expenditure(% of government expenditure on education) in Spain in 2004 to that in 2005?
Offer a very short reply. 1.02. What is the ratio of the Expenditure(% of government expenditure on education) in Tunisia in 2004 to that in 2005?
Provide a short and direct response. 1.1. What is the ratio of the Expenditure(% of government expenditure on education) in Mexico in 2004 to that in 2006?
Your answer should be very brief. 1.01. What is the ratio of the Expenditure(% of government expenditure on education) of Portugal in 2004 to that in 2006?
Keep it short and to the point. 0.87. What is the ratio of the Expenditure(% of government expenditure on education) of Spain in 2004 to that in 2006?
Offer a terse response. 1.03. What is the ratio of the Expenditure(% of government expenditure on education) of Tunisia in 2004 to that in 2006?
Give a very brief answer. 1.1. What is the ratio of the Expenditure(% of government expenditure on education) in Mexico in 2004 to that in 2007?
Keep it short and to the point. 0.94. What is the ratio of the Expenditure(% of government expenditure on education) in Portugal in 2004 to that in 2007?
Provide a succinct answer. 0.73. What is the ratio of the Expenditure(% of government expenditure on education) of Spain in 2004 to that in 2007?
Keep it short and to the point. 1. What is the ratio of the Expenditure(% of government expenditure on education) of Tunisia in 2004 to that in 2007?
Offer a terse response. 1.08. What is the ratio of the Expenditure(% of government expenditure on education) of Mexico in 2004 to that in 2008?
Your response must be concise. 0.92. What is the ratio of the Expenditure(% of government expenditure on education) in Portugal in 2004 to that in 2008?
Keep it short and to the point. 0.85. What is the ratio of the Expenditure(% of government expenditure on education) of Spain in 2004 to that in 2008?
Your response must be concise. 0.99. What is the ratio of the Expenditure(% of government expenditure on education) of Tunisia in 2004 to that in 2008?
Provide a short and direct response. 1.07. What is the ratio of the Expenditure(% of government expenditure on education) of Mexico in 2005 to that in 2006?
Give a very brief answer. 1.01. What is the ratio of the Expenditure(% of government expenditure on education) in Portugal in 2005 to that in 2006?
Your answer should be very brief. 0.95. What is the ratio of the Expenditure(% of government expenditure on education) of Tunisia in 2005 to that in 2006?
Provide a short and direct response. 1. What is the ratio of the Expenditure(% of government expenditure on education) of Mexico in 2005 to that in 2007?
Give a very brief answer. 0.94. What is the ratio of the Expenditure(% of government expenditure on education) in Portugal in 2005 to that in 2007?
Keep it short and to the point. 0.8. What is the ratio of the Expenditure(% of government expenditure on education) in Spain in 2005 to that in 2007?
Give a very brief answer. 0.98. What is the ratio of the Expenditure(% of government expenditure on education) of Tunisia in 2005 to that in 2007?
Provide a short and direct response. 0.98. What is the ratio of the Expenditure(% of government expenditure on education) in Mexico in 2005 to that in 2008?
Keep it short and to the point. 0.93. What is the ratio of the Expenditure(% of government expenditure on education) of Portugal in 2005 to that in 2008?
Your answer should be compact. 0.94. What is the ratio of the Expenditure(% of government expenditure on education) of Tunisia in 2005 to that in 2008?
Ensure brevity in your answer.  0.97. What is the ratio of the Expenditure(% of government expenditure on education) in Mexico in 2006 to that in 2007?
Provide a succinct answer. 0.93. What is the ratio of the Expenditure(% of government expenditure on education) of Portugal in 2006 to that in 2007?
Give a very brief answer. 0.84. What is the ratio of the Expenditure(% of government expenditure on education) in Spain in 2006 to that in 2007?
Offer a terse response. 0.97. What is the ratio of the Expenditure(% of government expenditure on education) in Tunisia in 2006 to that in 2007?
Offer a very short reply. 0.99. What is the ratio of the Expenditure(% of government expenditure on education) in Mexico in 2006 to that in 2008?
Your answer should be compact. 0.91. What is the ratio of the Expenditure(% of government expenditure on education) in Portugal in 2006 to that in 2008?
Keep it short and to the point. 0.98. What is the ratio of the Expenditure(% of government expenditure on education) of Spain in 2006 to that in 2008?
Your response must be concise. 0.96. What is the ratio of the Expenditure(% of government expenditure on education) in Tunisia in 2006 to that in 2008?
Your response must be concise. 0.97. What is the ratio of the Expenditure(% of government expenditure on education) of Mexico in 2007 to that in 2008?
Give a very brief answer. 0.98. What is the ratio of the Expenditure(% of government expenditure on education) of Portugal in 2007 to that in 2008?
Provide a short and direct response. 1.17. What is the ratio of the Expenditure(% of government expenditure on education) in Tunisia in 2007 to that in 2008?
Offer a very short reply. 0.98. What is the difference between the highest and the second highest Expenditure(% of government expenditure on education) in Mexico?
Provide a short and direct response. 0.76. What is the difference between the highest and the second highest Expenditure(% of government expenditure on education) of Portugal?
Give a very brief answer. 3.34. What is the difference between the highest and the second highest Expenditure(% of government expenditure on education) of Spain?
Keep it short and to the point. 0.14. What is the difference between the highest and the second highest Expenditure(% of government expenditure on education) in Tunisia?
Keep it short and to the point. 1.63. What is the difference between the highest and the lowest Expenditure(% of government expenditure on education) in Mexico?
Your answer should be very brief. 2.76. What is the difference between the highest and the lowest Expenditure(% of government expenditure on education) in Portugal?
Your response must be concise. 6.2. What is the difference between the highest and the lowest Expenditure(% of government expenditure on education) in Spain?
Provide a short and direct response. 0.97. What is the difference between the highest and the lowest Expenditure(% of government expenditure on education) in Tunisia?
Provide a short and direct response. 3.85. 